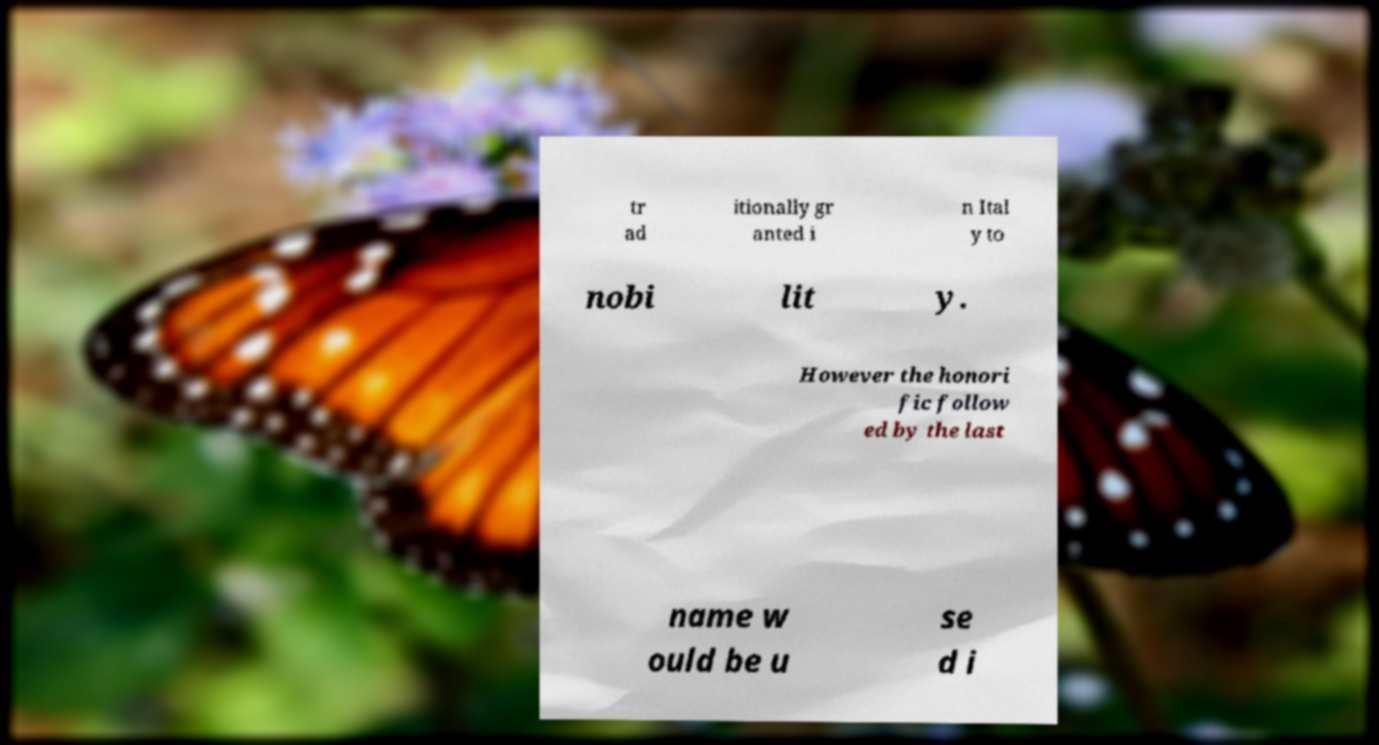For documentation purposes, I need the text within this image transcribed. Could you provide that? tr ad itionally gr anted i n Ital y to nobi lit y. However the honori fic follow ed by the last name w ould be u se d i 